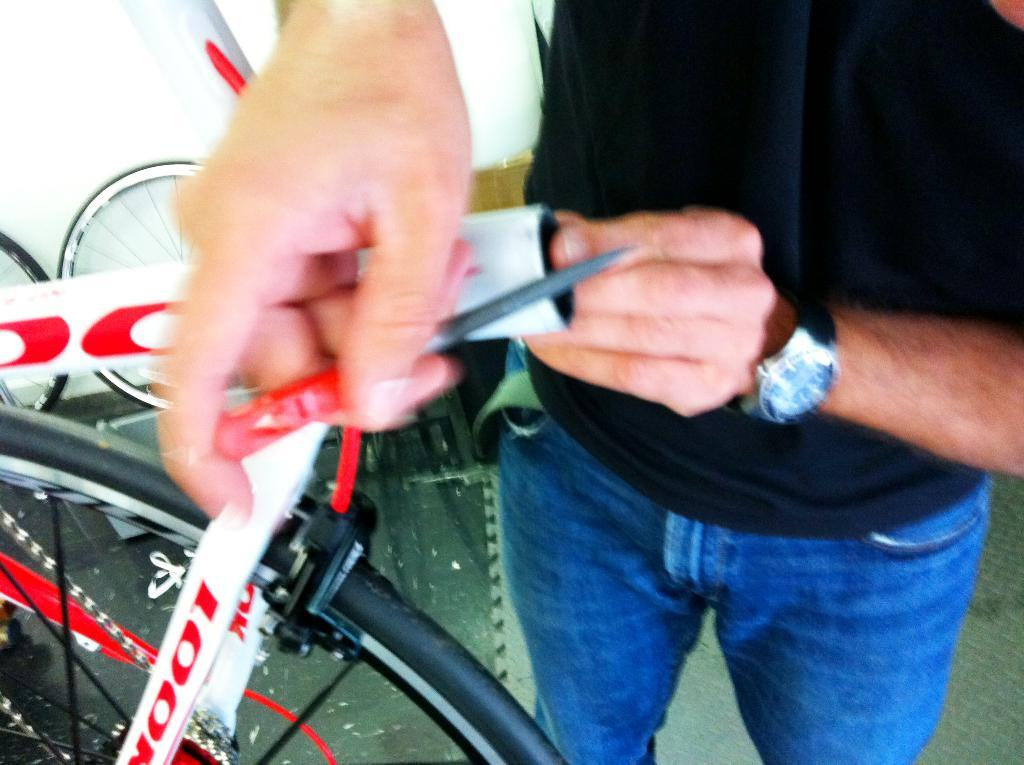What is the person in the image doing? The person is standing on the floor and holding a tool and a metal rod. What can be seen near the person in the image? There are tires visible in the image. What is the background of the image? There is a wall in the image. What type of knot is the person using to secure the metal rod in the image? There is no knot present in the image, as the person is holding the metal rod, not tying it. What decisions is the committee making in the image? There is no committee present in the image, as it only features a person holding a tool and a metal rod, tires, and a wall. 